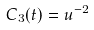Convert formula to latex. <formula><loc_0><loc_0><loc_500><loc_500>C _ { 3 } ( t ) = u ^ { - 2 }</formula> 